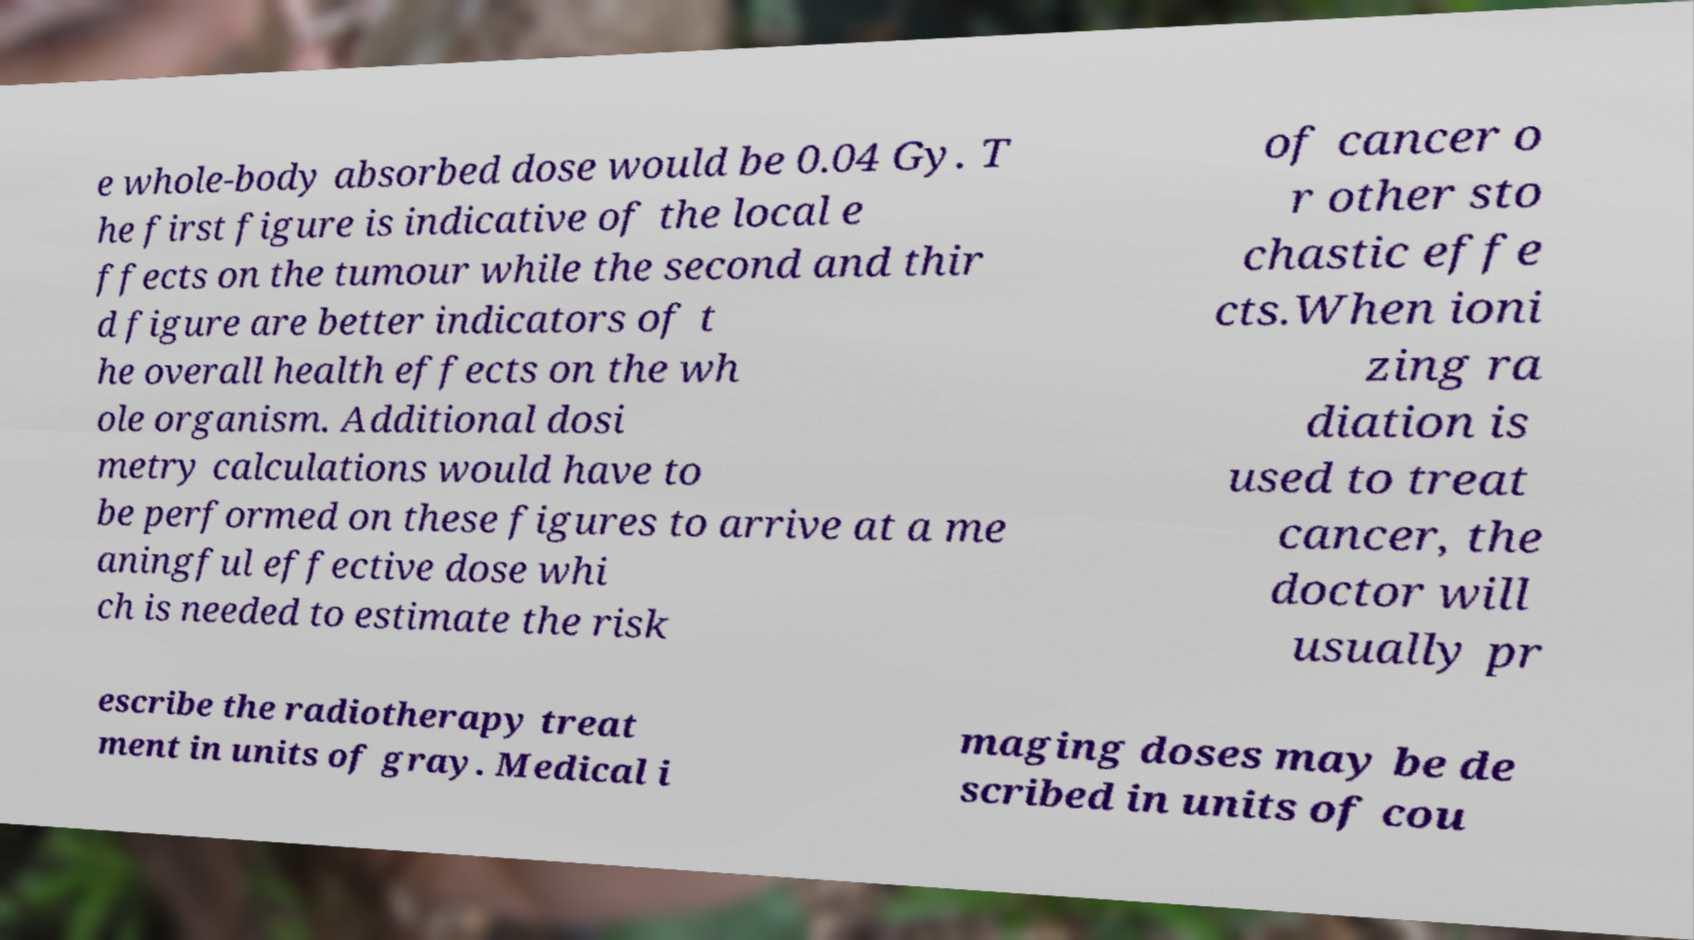Could you assist in decoding the text presented in this image and type it out clearly? e whole-body absorbed dose would be 0.04 Gy. T he first figure is indicative of the local e ffects on the tumour while the second and thir d figure are better indicators of t he overall health effects on the wh ole organism. Additional dosi metry calculations would have to be performed on these figures to arrive at a me aningful effective dose whi ch is needed to estimate the risk of cancer o r other sto chastic effe cts.When ioni zing ra diation is used to treat cancer, the doctor will usually pr escribe the radiotherapy treat ment in units of gray. Medical i maging doses may be de scribed in units of cou 